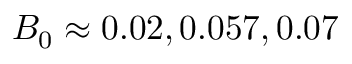<formula> <loc_0><loc_0><loc_500><loc_500>B _ { 0 } \approx 0 . 0 2 , 0 . 0 5 7 , 0 . 0 7</formula> 